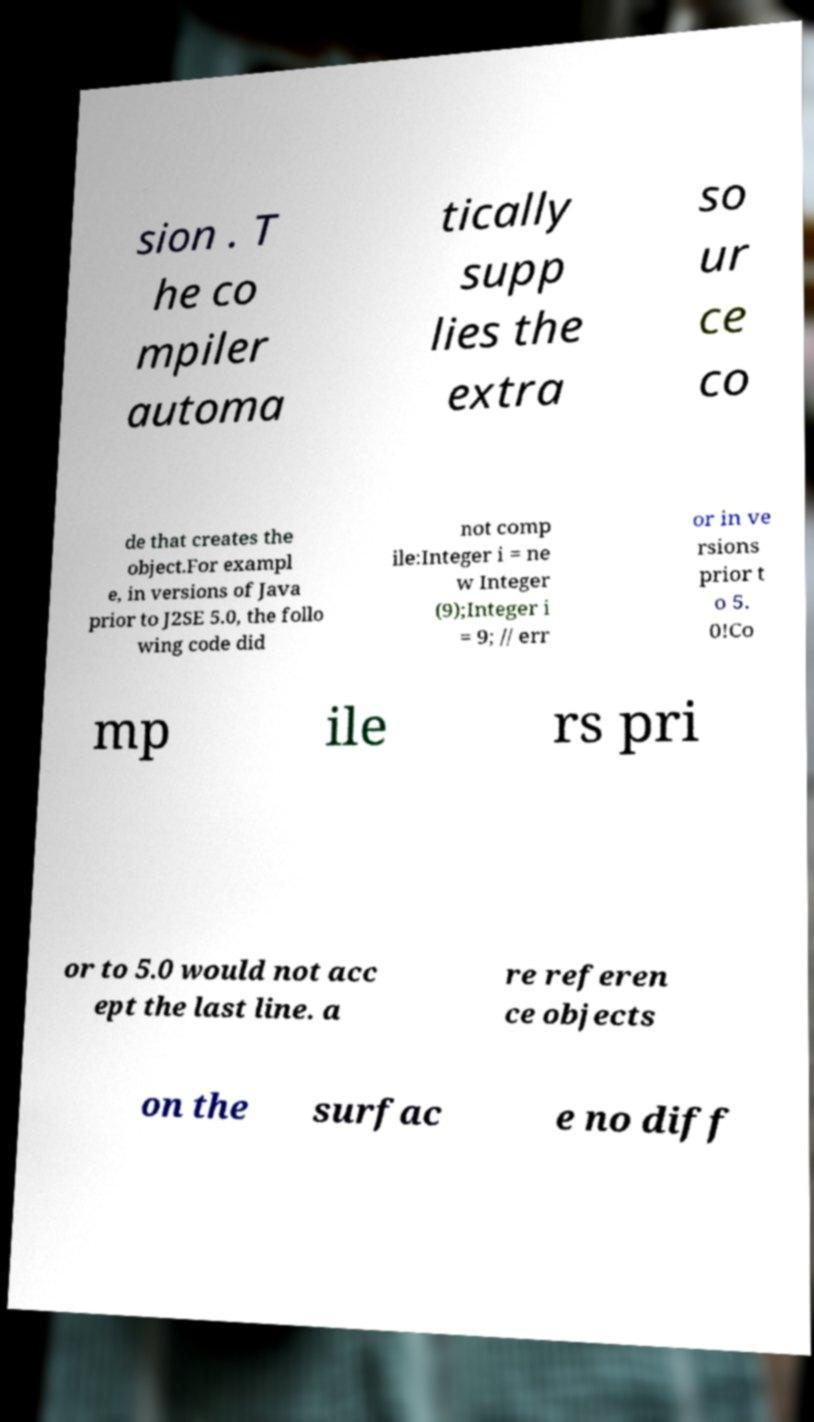Please read and relay the text visible in this image. What does it say? sion . T he co mpiler automa tically supp lies the extra so ur ce co de that creates the object.For exampl e, in versions of Java prior to J2SE 5.0, the follo wing code did not comp ile:Integer i = ne w Integer (9);Integer i = 9; // err or in ve rsions prior t o 5. 0!Co mp ile rs pri or to 5.0 would not acc ept the last line. a re referen ce objects on the surfac e no diff 